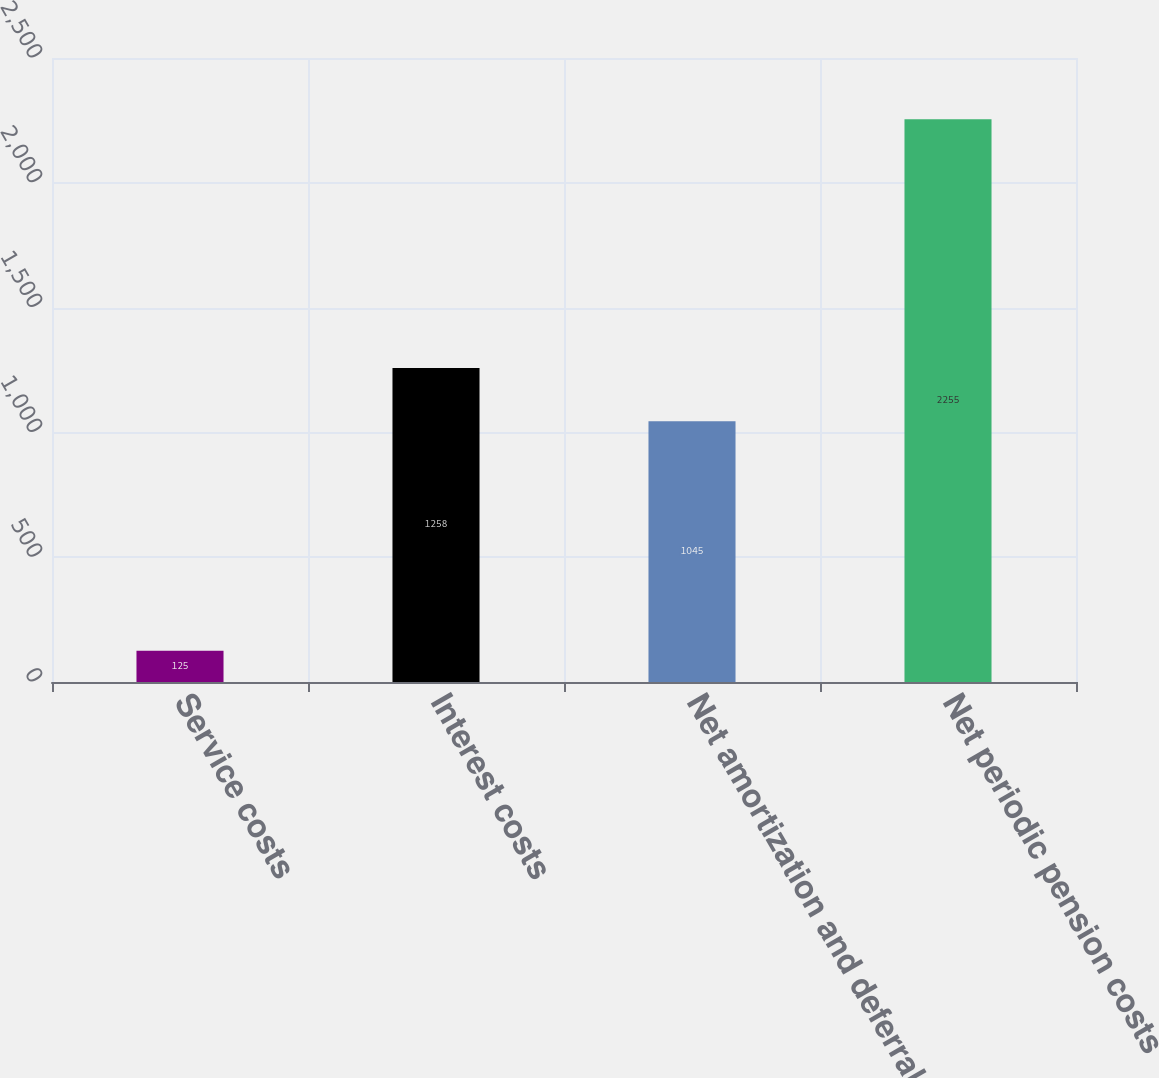<chart> <loc_0><loc_0><loc_500><loc_500><bar_chart><fcel>Service costs<fcel>Interest costs<fcel>Net amortization and deferral<fcel>Net periodic pension costs<nl><fcel>125<fcel>1258<fcel>1045<fcel>2255<nl></chart> 